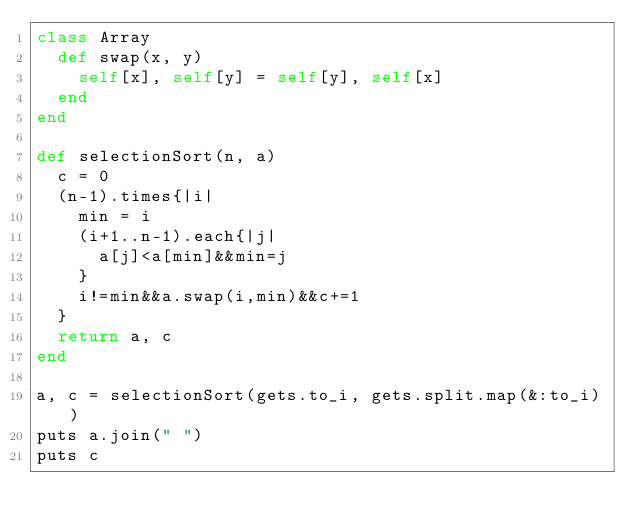<code> <loc_0><loc_0><loc_500><loc_500><_Ruby_>class Array
  def swap(x, y)
    self[x], self[y] = self[y], self[x]
  end
end

def selectionSort(n, a)
  c = 0
  (n-1).times{|i|
    min = i
    (i+1..n-1).each{|j|
      a[j]<a[min]&&min=j
    }
    i!=min&&a.swap(i,min)&&c+=1
  }
  return a, c
end

a, c = selectionSort(gets.to_i, gets.split.map(&:to_i))
puts a.join(" ")
puts c</code> 